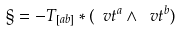<formula> <loc_0><loc_0><loc_500><loc_500>\S = - T _ { [ a b ] } * ( \ v t ^ { a } \wedge \ v t ^ { b } )</formula> 